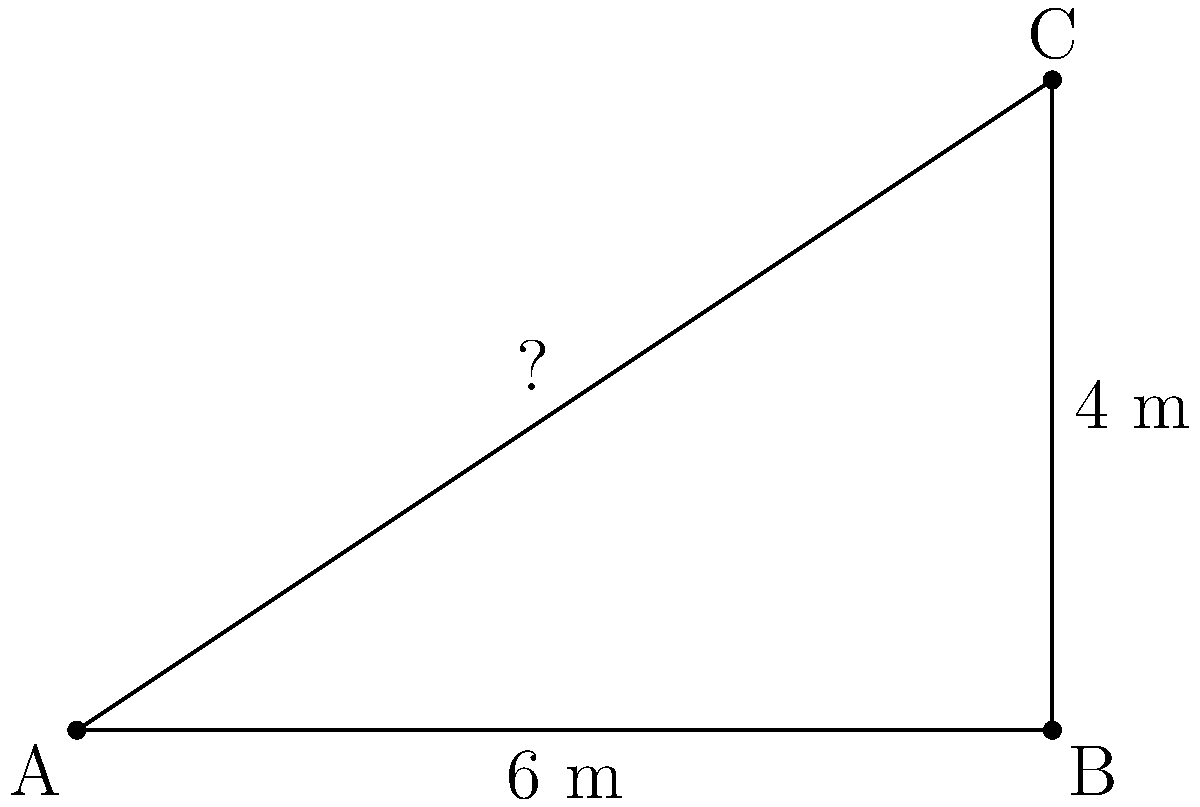A rural school is planning to install a new flagpole in their courtyard. To ensure stability, they need to attach a support cable from the top of the 6-meter tall flagpole to a ground anchor 4 meters away from its base. What length of cable should the school purchase to reach from the top of the flagpole to the ground anchor? Let's approach this step-by-step using the Pythagorean theorem:

1) First, we identify the right triangle formed by the flagpole, the ground, and the cable.
   - The flagpole forms the vertical side (height) of 6 meters.
   - The distance from the base of the flagpole to the anchor forms the horizontal side (base) of 4 meters.
   - The cable forms the hypotenuse, which is what we need to find.

2) We can apply the Pythagorean theorem: $a^2 + b^2 = c^2$
   Where:
   $a$ = height of the flagpole (6 m)
   $b$ = distance to the anchor (4 m)
   $c$ = length of the cable (unknown)

3) Let's substitute these values:
   $6^2 + 4^2 = c^2$

4) Simplify:
   $36 + 16 = c^2$
   $52 = c^2$

5) To find $c$, we need to take the square root of both sides:
   $\sqrt{52} = c$

6) Simplify the square root:
   $c = 2\sqrt{13} \approx 7.21$ meters

Therefore, the school should purchase a cable that is approximately 7.21 meters long.
Answer: $2\sqrt{13}$ m or approximately 7.21 m 